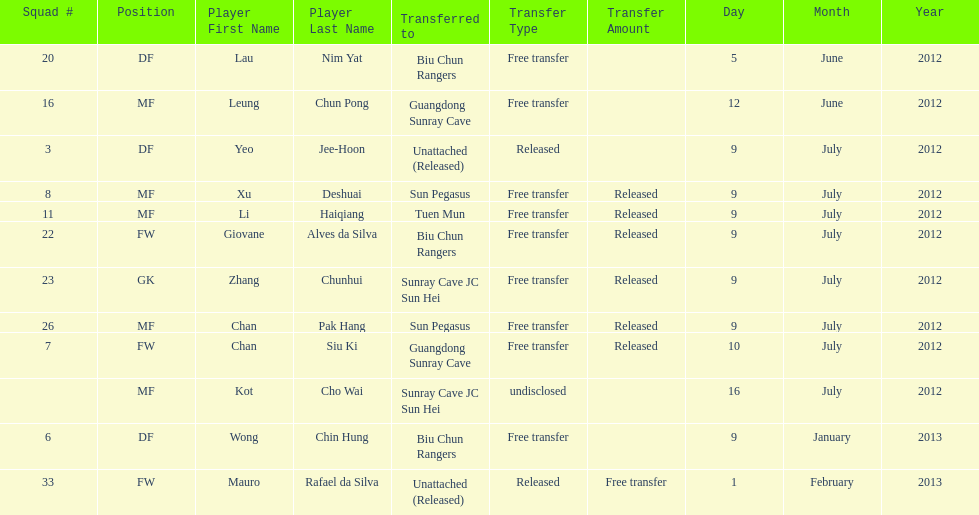Write the full table. {'header': ['Squad #', 'Position', 'Player First Name', 'Player Last Name', 'Transferred to', 'Transfer Type', 'Transfer Amount', 'Day', 'Month', 'Year'], 'rows': [['20', 'DF', 'Lau', 'Nim Yat', 'Biu Chun Rangers', 'Free transfer', '', '5', 'June', '2012'], ['16', 'MF', 'Leung', 'Chun Pong', 'Guangdong Sunray Cave', 'Free transfer', '', '12', 'June', '2012'], ['3', 'DF', 'Yeo', 'Jee-Hoon', 'Unattached (Released)', 'Released', '', '9', 'July', '2012'], ['8', 'MF', 'Xu', 'Deshuai', 'Sun Pegasus', 'Free transfer', 'Released', '9', 'July', '2012'], ['11', 'MF', 'Li', 'Haiqiang', 'Tuen Mun', 'Free transfer', 'Released', '9', 'July', '2012'], ['22', 'FW', 'Giovane', 'Alves da Silva', 'Biu Chun Rangers', 'Free transfer', 'Released', '9', 'July', '2012'], ['23', 'GK', 'Zhang', 'Chunhui', 'Sunray Cave JC Sun Hei', 'Free transfer', 'Released', '9', 'July', '2012'], ['26', 'MF', 'Chan', 'Pak Hang', 'Sun Pegasus', 'Free transfer', 'Released', '9', 'July', '2012'], ['7', 'FW', 'Chan', 'Siu Ki', 'Guangdong Sunray Cave', 'Free transfer', 'Released', '10', 'July', '2012'], ['', 'MF', 'Kot', 'Cho Wai', 'Sunray Cave JC Sun Hei', 'undisclosed', '', '16', 'July', '2012'], ['6', 'DF', 'Wong', 'Chin Hung', 'Biu Chun Rangers', 'Free transfer', '', '9', 'January', '2013'], ['33', 'FW', 'Mauro', 'Rafael da Silva', 'Unattached (Released)', 'Released', 'Free transfer', '1', 'February', '2013']]} What position is next to squad # 3? DF. 